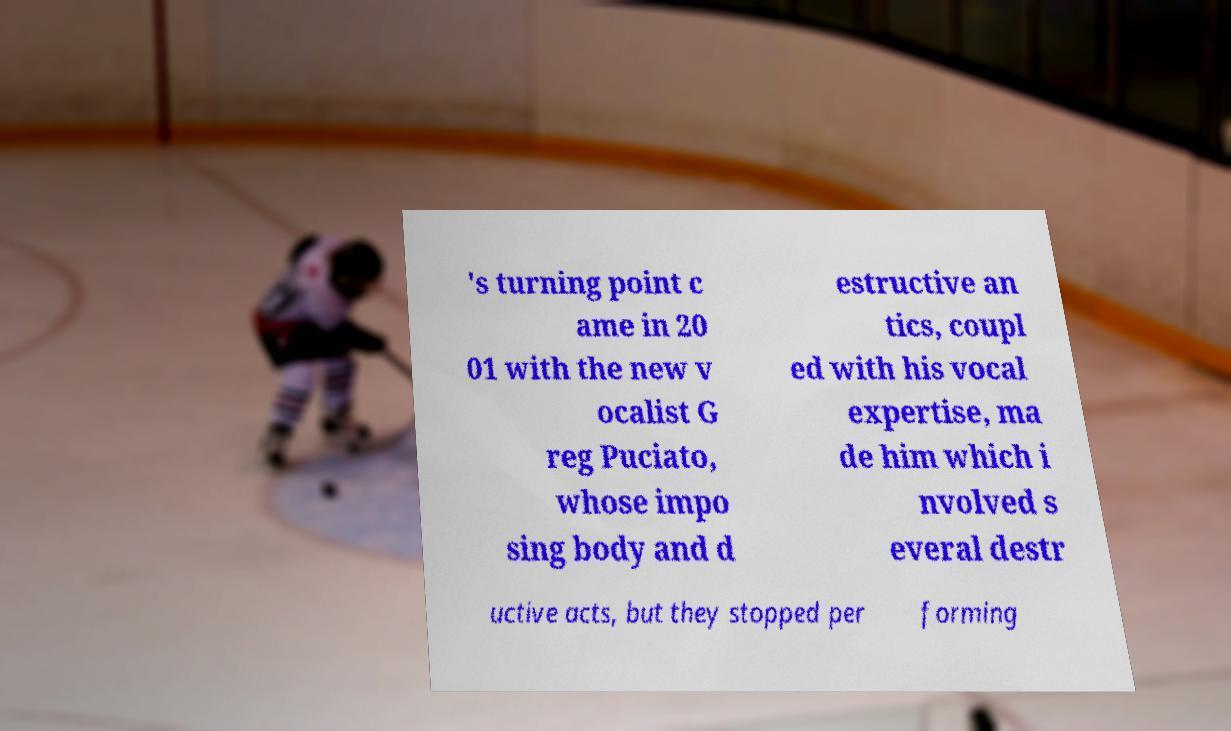Please read and relay the text visible in this image. What does it say? 's turning point c ame in 20 01 with the new v ocalist G reg Puciato, whose impo sing body and d estructive an tics, coupl ed with his vocal expertise, ma de him which i nvolved s everal destr uctive acts, but they stopped per forming 